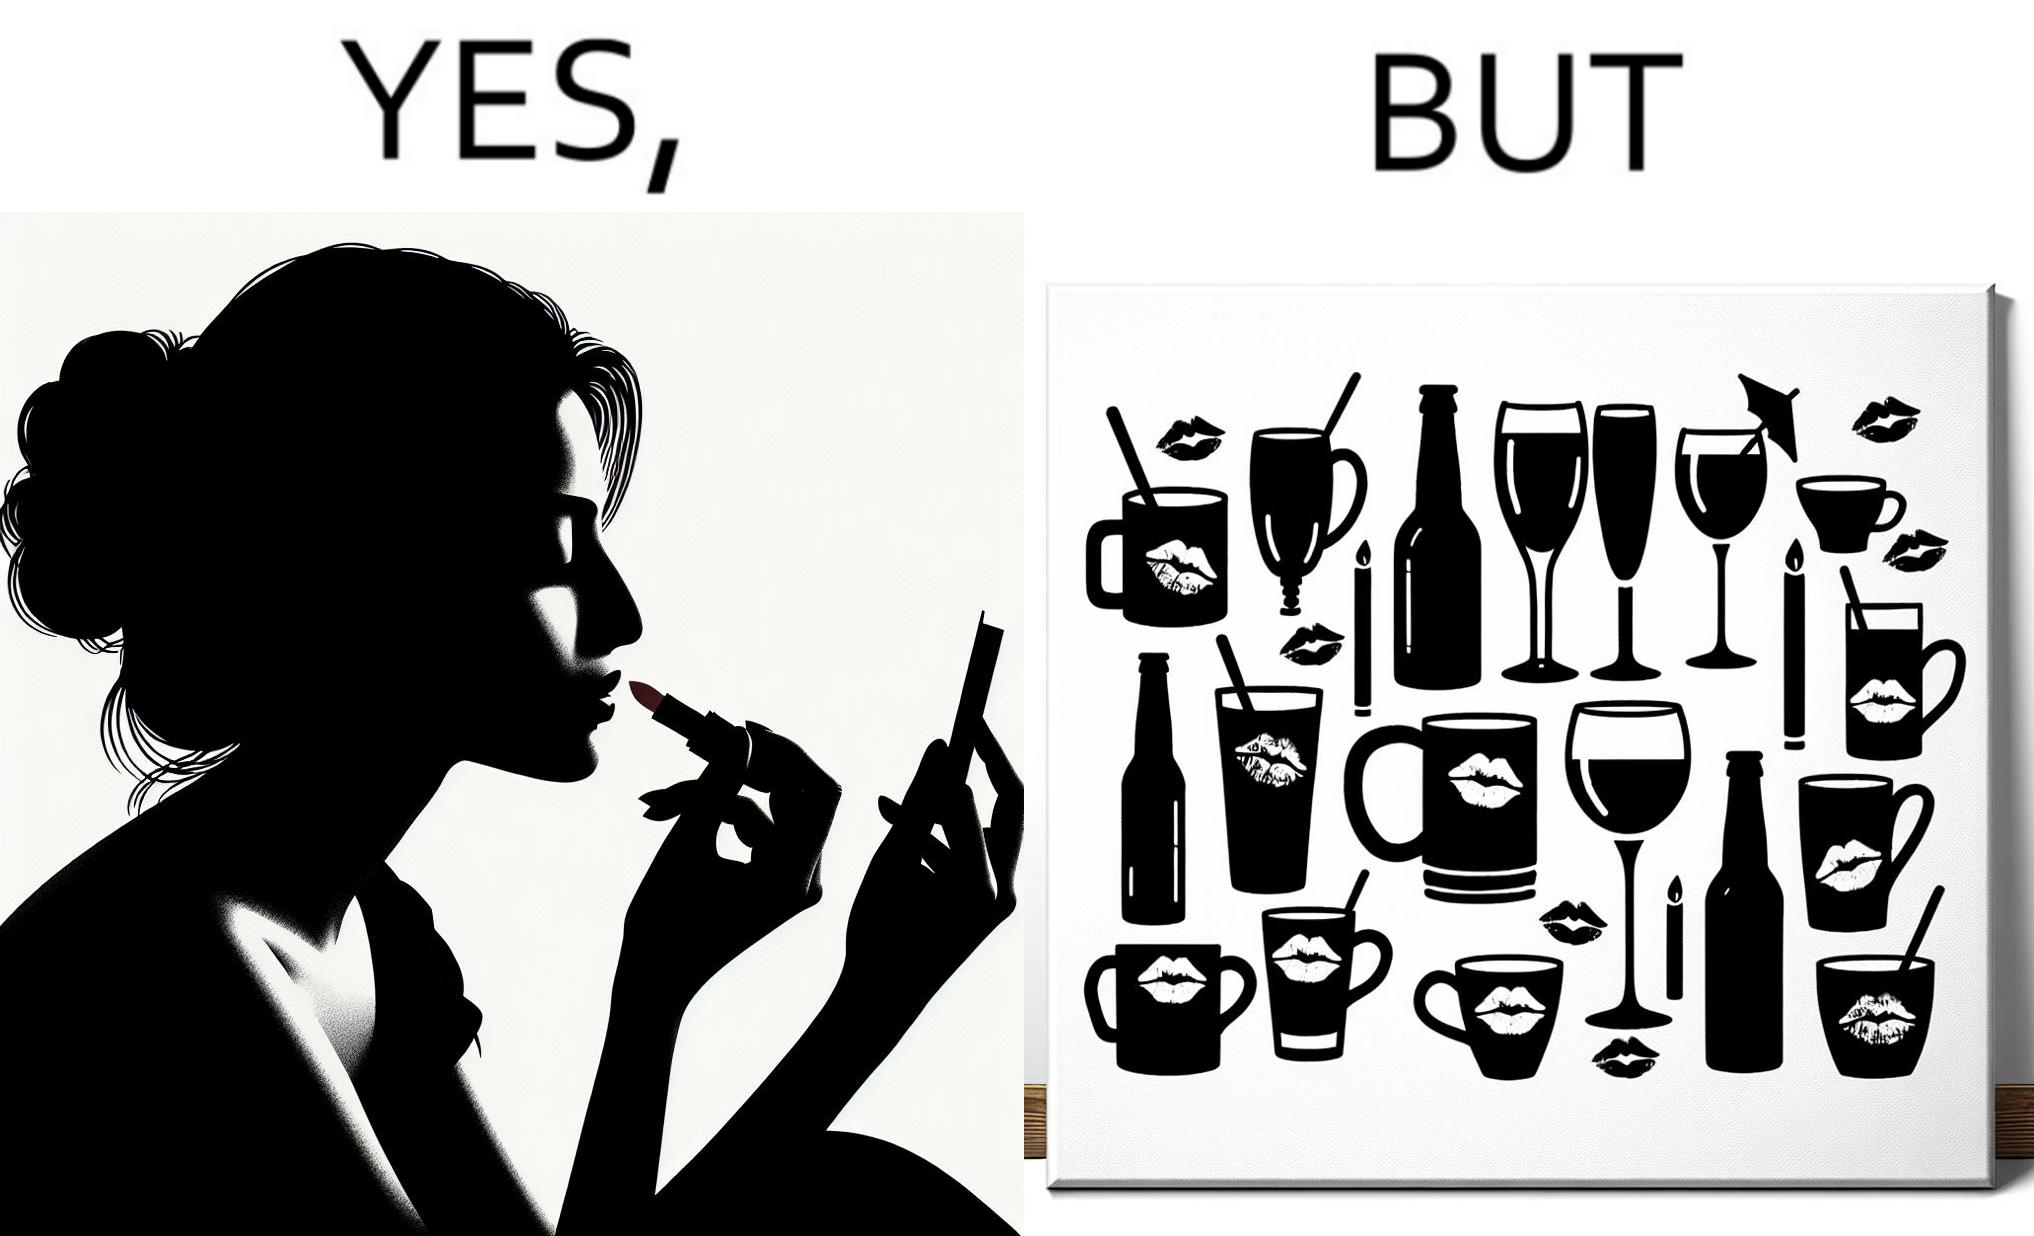Explain why this image is satirical. The image is ironic, because the left image suggest that a person applies lipsticks on their lips to make their lips look attractive or to keep them hydrated but on the contrary it gets sticked to the glasses or mugs and gets wasted 